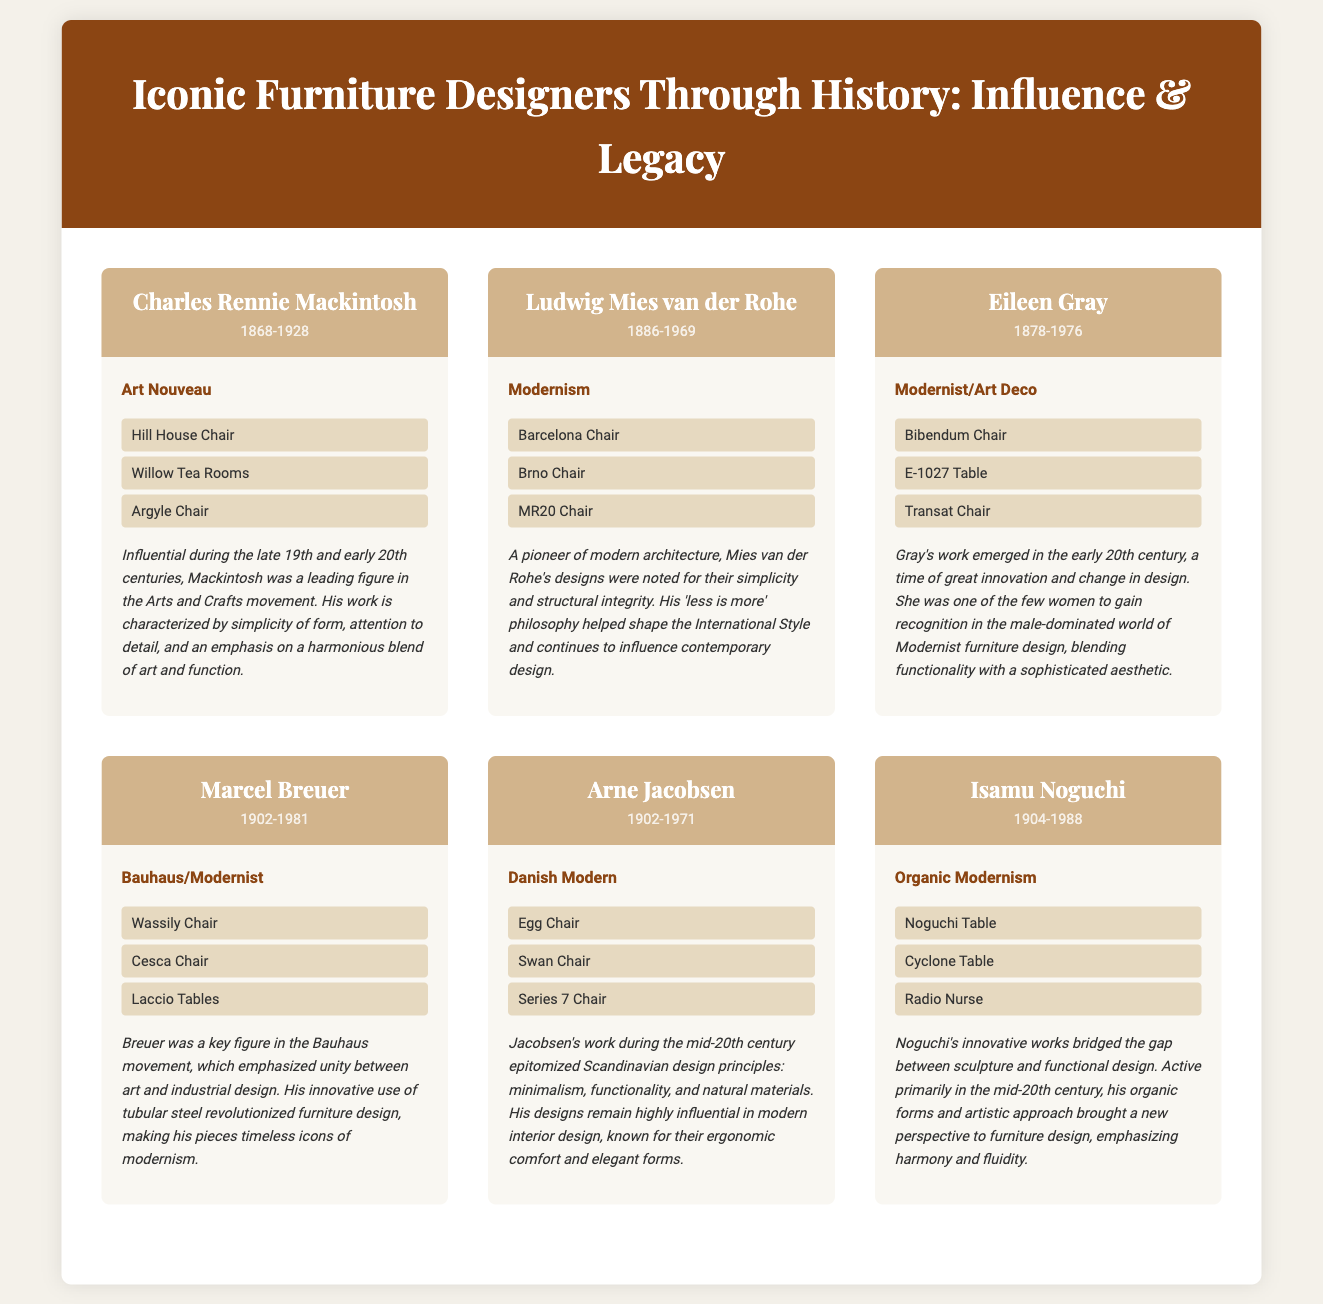What is the name of the designer associated with the Egg Chair? The Egg Chair is an iconic piece designed by Arne Jacobsen.
Answer: Arne Jacobsen What period did Eileen Gray work in? Eileen Gray was active from 1878 to 1976, thus her period is identified as the early to mid-20th century.
Answer: 1878-1976 Which furniture designer is known for the Barcelona Chair? The Barcelona Chair is famously associated with Ludwig Mies van der Rohe.
Answer: Ludwig Mies van der Rohe What style did Marcel Breuer's designs represent? Marcel Breuer's designs are characterized by the Bauhaus and Modernist styles.
Answer: Bauhaus/Modernist How many iconic pieces are listed for Isamu Noguchi? The document lists three iconic pieces designed by Isamu Noguchi.
Answer: Three What is the main theme of the historical context for Charles Rennie Mackintosh? The historical context highlights his influence in the Arts and Crafts movement and his design philosophy.
Answer: Arts and Crafts movement Who is noted for the Transat Chair? The Transat Chair is one of the iconic pieces designed by Eileen Gray.
Answer: Eileen Gray What principle is associated with Ludwig Mies van der Rohe's philosophy? Mies van der Rohe is noted for his 'less is more' philosophy in design.
Answer: Less is more Which designer had a significant impact on Scandinavian design? Arne Jacobsen significantly influenced Scandinavian design principles during the mid-20th century.
Answer: Arne Jacobsen 